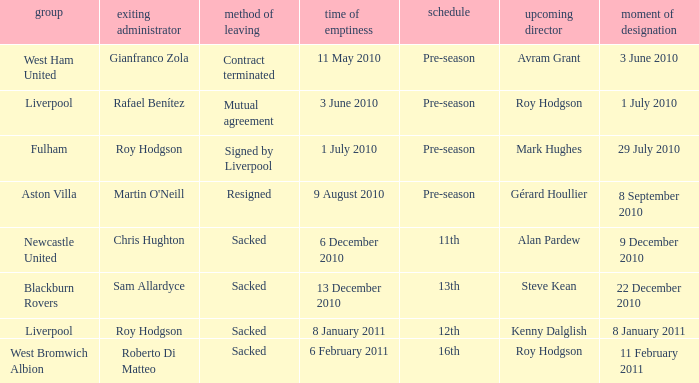What is the table for the team Blackburn Rovers? 13th. 